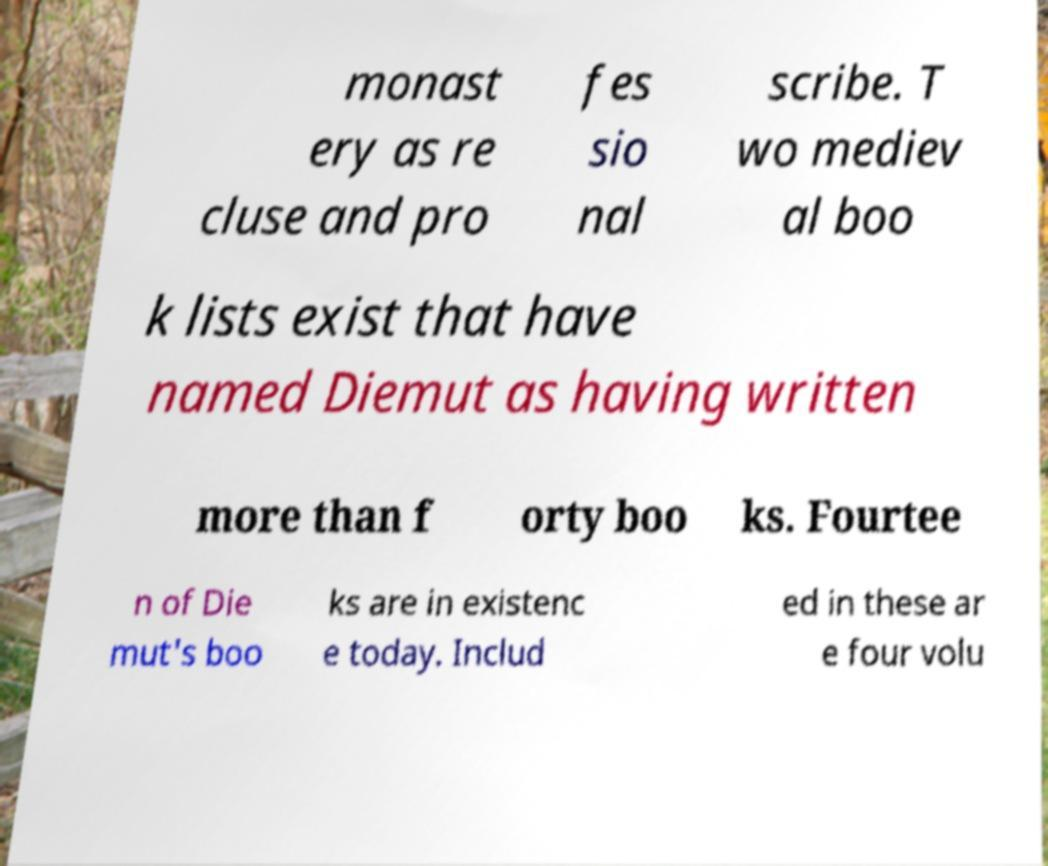Please read and relay the text visible in this image. What does it say? monast ery as re cluse and pro fes sio nal scribe. T wo mediev al boo k lists exist that have named Diemut as having written more than f orty boo ks. Fourtee n of Die mut's boo ks are in existenc e today. Includ ed in these ar e four volu 